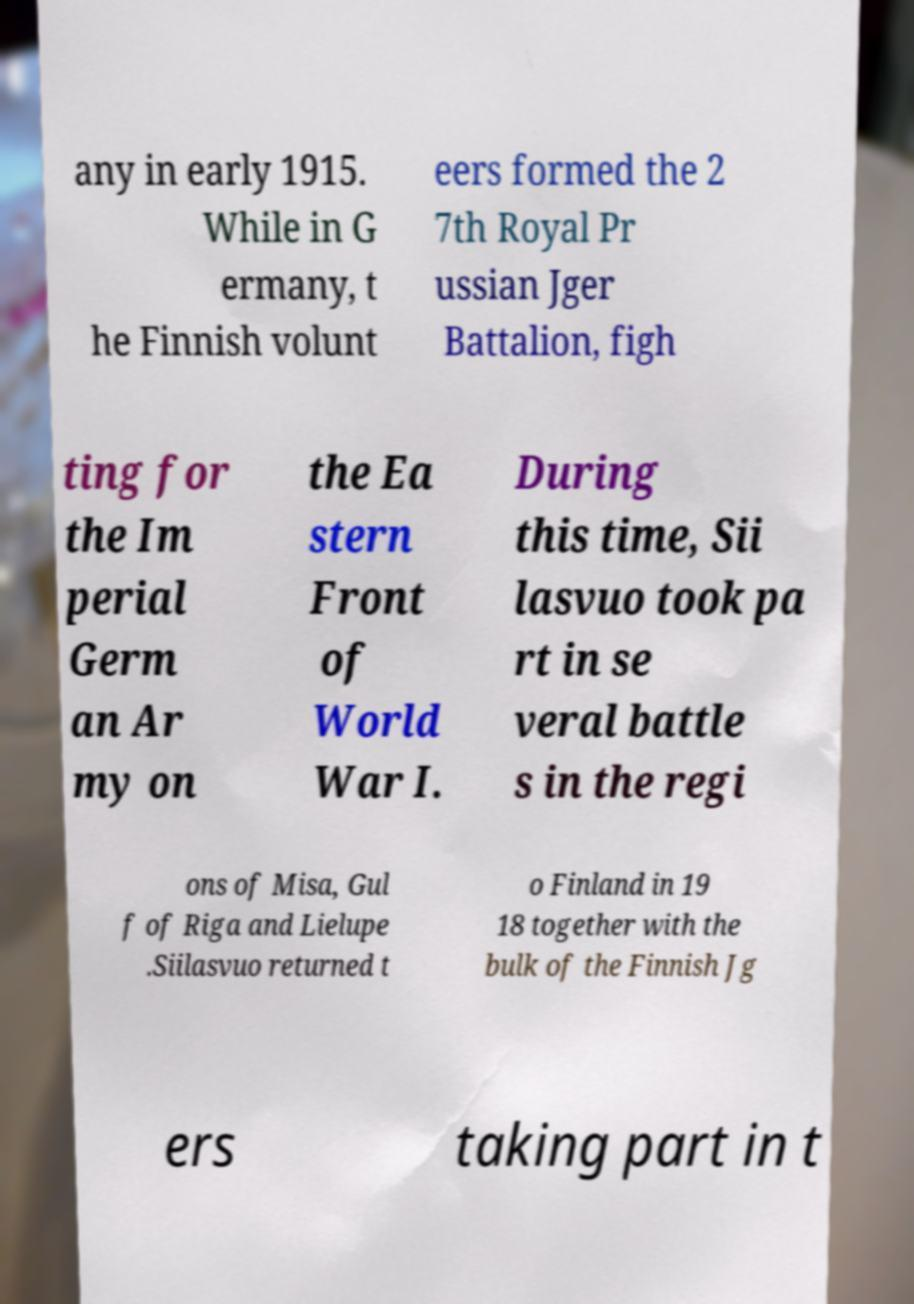For documentation purposes, I need the text within this image transcribed. Could you provide that? any in early 1915. While in G ermany, t he Finnish volunt eers formed the 2 7th Royal Pr ussian Jger Battalion, figh ting for the Im perial Germ an Ar my on the Ea stern Front of World War I. During this time, Sii lasvuo took pa rt in se veral battle s in the regi ons of Misa, Gul f of Riga and Lielupe .Siilasvuo returned t o Finland in 19 18 together with the bulk of the Finnish Jg ers taking part in t 